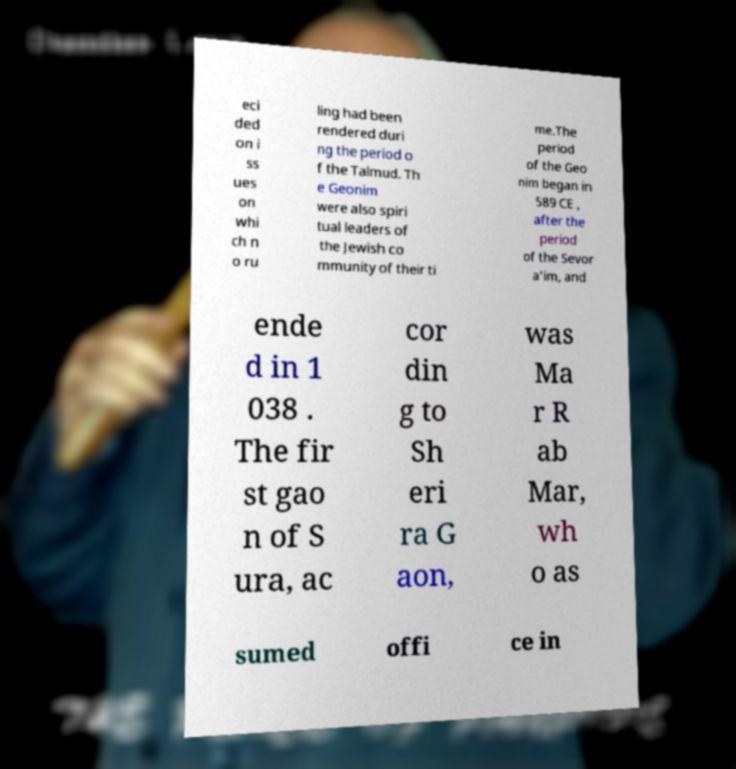Can you read and provide the text displayed in the image?This photo seems to have some interesting text. Can you extract and type it out for me? eci ded on i ss ues on whi ch n o ru ling had been rendered duri ng the period o f the Talmud. Th e Geonim were also spiri tual leaders of the Jewish co mmunity of their ti me.The period of the Geo nim began in 589 CE , after the period of the Sevor a'im, and ende d in 1 038 . The fir st gao n of S ura, ac cor din g to Sh eri ra G aon, was Ma r R ab Mar, wh o as sumed offi ce in 